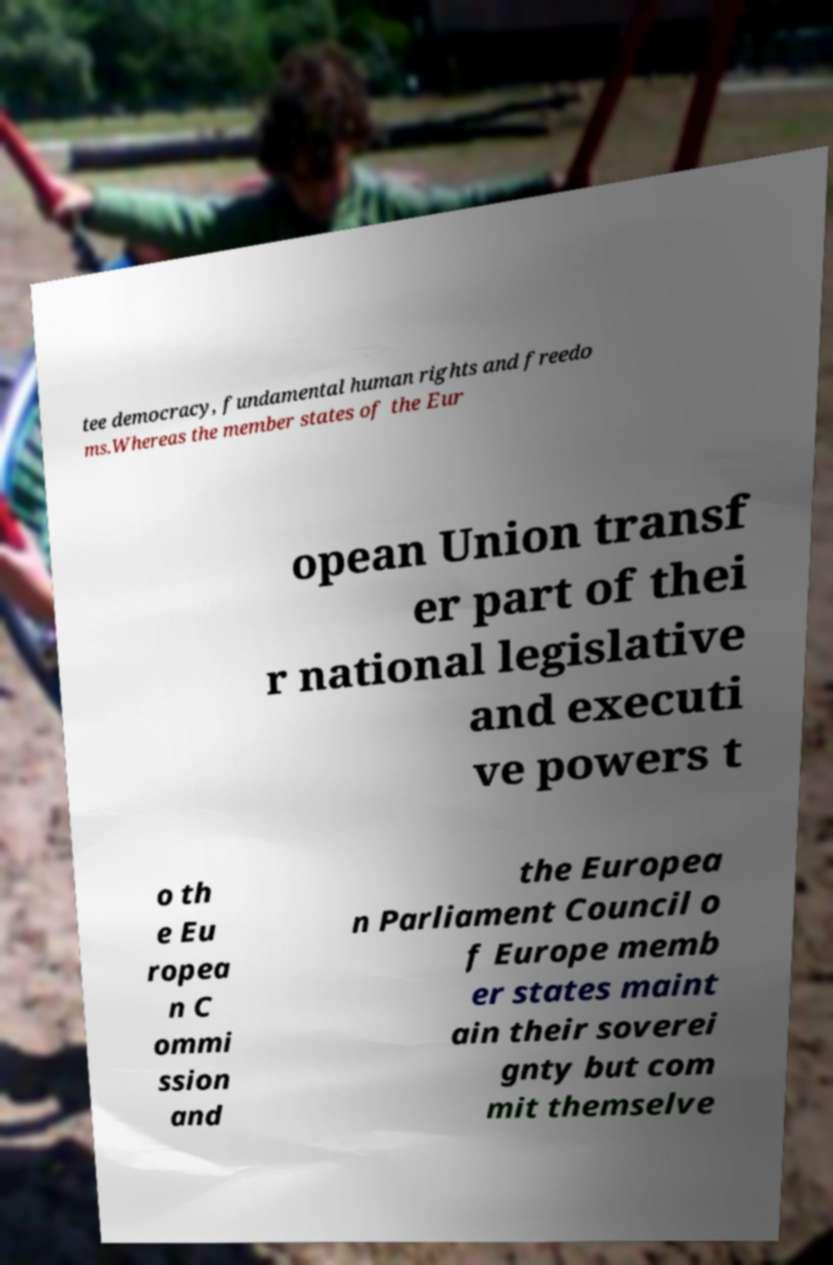Can you accurately transcribe the text from the provided image for me? tee democracy, fundamental human rights and freedo ms.Whereas the member states of the Eur opean Union transf er part of thei r national legislative and executi ve powers t o th e Eu ropea n C ommi ssion and the Europea n Parliament Council o f Europe memb er states maint ain their soverei gnty but com mit themselve 